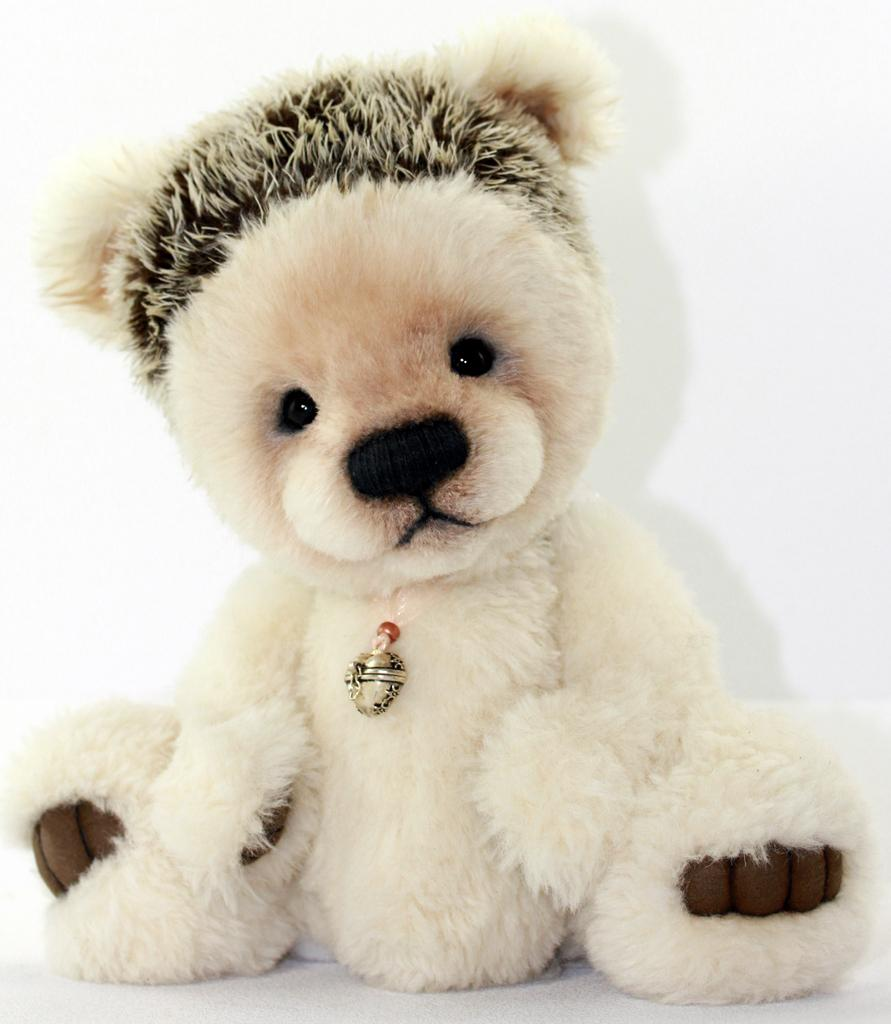What color is the background of the image? The background of the image is white. What type of toy can be seen in the image? There is a teddy bear in the image. What is the small, jewelry-like object in the image? There is a locket in the image. What type of vehicle is parked on the stage in the image? There is no stage or vehicle present in the image. How many sponges are visible on the van in the image? There are no sponges or vans present in the image. 